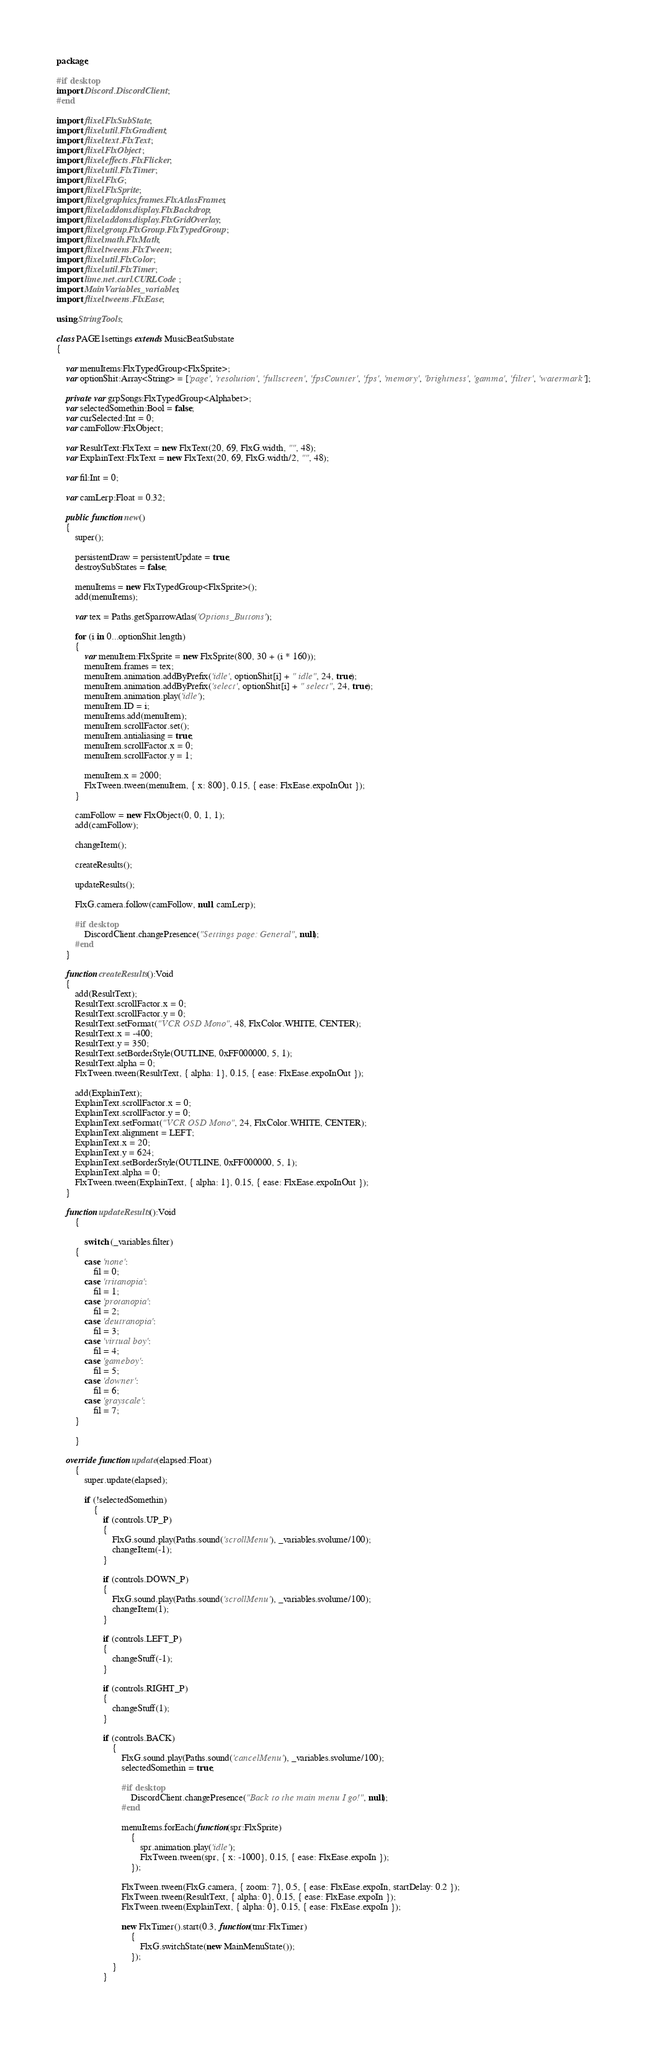Convert code to text. <code><loc_0><loc_0><loc_500><loc_500><_Haxe_>package;

#if desktop
import Discord.DiscordClient;
#end

import flixel.FlxSubState;
import flixel.util.FlxGradient;
import flixel.text.FlxText;
import flixel.FlxObject;
import flixel.effects.FlxFlicker;
import flixel.util.FlxTimer;
import flixel.FlxG;
import flixel.FlxSprite;
import flixel.graphics.frames.FlxAtlasFrames;
import flixel.addons.display.FlxBackdrop;
import flixel.addons.display.FlxGridOverlay;
import flixel.group.FlxGroup.FlxTypedGroup;
import flixel.math.FlxMath;
import flixel.tweens.FlxTween;
import flixel.util.FlxColor;
import flixel.util.FlxTimer;
import lime.net.curl.CURLCode;
import MainVariables._variables;
import flixel.tweens.FlxEase;

using StringTools;

class PAGE1settings extends MusicBeatSubstate
{

    var menuItems:FlxTypedGroup<FlxSprite>;
    var optionShit:Array<String> = ['page', 'resolution', 'fullscreen', 'fpsCounter', 'fps', 'memory', 'brightness', 'gamma', 'filter', 'watermark'];

    private var grpSongs:FlxTypedGroup<Alphabet>;
    var selectedSomethin:Bool = false;
    var curSelected:Int = 0;
    var camFollow:FlxObject;

    var ResultText:FlxText = new FlxText(20, 69, FlxG.width, "", 48);
    var ExplainText:FlxText = new FlxText(20, 69, FlxG.width/2, "", 48);

    var fil:Int = 0;

    var camLerp:Float = 0.32;

    public function new()
    {
        super();

        persistentDraw = persistentUpdate = true;
        destroySubStates = false;

        menuItems = new FlxTypedGroup<FlxSprite>();
        add(menuItems);
        
		var tex = Paths.getSparrowAtlas('Options_Buttons');

		for (i in 0...optionShit.length)
		{
			var menuItem:FlxSprite = new FlxSprite(800, 30 + (i * 160));
			menuItem.frames = tex;
            menuItem.animation.addByPrefix('idle', optionShit[i] + " idle", 24, true);
            menuItem.animation.addByPrefix('select', optionShit[i] + " select", 24, true);
			menuItem.animation.play('idle');
			menuItem.ID = i;
			menuItems.add(menuItem);
			menuItem.scrollFactor.set();
            menuItem.antialiasing = true;
            menuItem.scrollFactor.x = 0;
            menuItem.scrollFactor.y = 1;

            menuItem.x = 2000;
            FlxTween.tween(menuItem, { x: 800}, 0.15, { ease: FlxEase.expoInOut });
        }

        camFollow = new FlxObject(0, 0, 1, 1);
		add(camFollow);
        
        changeItem();

        createResults();

        updateResults();

        FlxG.camera.follow(camFollow, null, camLerp);

        #if desktop
			DiscordClient.changePresence("Settings page: General", null);
		#end
    }

    function createResults():Void
    {
        add(ResultText);
        ResultText.scrollFactor.x = 0;
        ResultText.scrollFactor.y = 0;
        ResultText.setFormat("VCR OSD Mono", 48, FlxColor.WHITE, CENTER);
        ResultText.x = -400;
        ResultText.y = 350;
        ResultText.setBorderStyle(OUTLINE, 0xFF000000, 5, 1);
        ResultText.alpha = 0;
        FlxTween.tween(ResultText, { alpha: 1}, 0.15, { ease: FlxEase.expoInOut });

        add(ExplainText);
        ExplainText.scrollFactor.x = 0;
        ExplainText.scrollFactor.y = 0;
        ExplainText.setFormat("VCR OSD Mono", 24, FlxColor.WHITE, CENTER);
        ExplainText.alignment = LEFT;
        ExplainText.x = 20;
        ExplainText.y = 624;
        ExplainText.setBorderStyle(OUTLINE, 0xFF000000, 5, 1);
        ExplainText.alpha = 0;
        FlxTween.tween(ExplainText, { alpha: 1}, 0.15, { ease: FlxEase.expoInOut });
    }

    function updateResults():Void
        {

            switch (_variables.filter)
        {
            case 'none':
                fil = 0;
            case 'tritanopia':
                fil = 1;
            case 'protanopia':
                fil = 2;
            case 'deutranopia':
                fil = 3;
            case 'virtual boy':
                fil = 4;
            case 'gameboy':
                fil = 5;
            case 'downer':
                fil = 6;
            case 'grayscale':
                fil = 7;
        }

        }

    override function update(elapsed:Float)
        {
            super.update(elapsed);

            if (!selectedSomethin)
                {
                    if (controls.UP_P)
                    {
                        FlxG.sound.play(Paths.sound('scrollMenu'), _variables.svolume/100);
                        changeItem(-1);
                    }
        
                    if (controls.DOWN_P)
                    {
                        FlxG.sound.play(Paths.sound('scrollMenu'), _variables.svolume/100);
                        changeItem(1);
                    }
			
				    if (controls.LEFT_P)
                    {
                        changeStuff(-1);
                    }
        
                    if (controls.RIGHT_P)
                    {
                        changeStuff(1);
                    }
                
                    if (controls.BACK)
                        {
                            FlxG.sound.play(Paths.sound('cancelMenu'), _variables.svolume/100);
                            selectedSomethin = true;

                            #if desktop
			                    DiscordClient.changePresence("Back to the main menu I go!", null);
		                    #end
    
                            menuItems.forEach(function(spr:FlxSprite)
                                {
                                    spr.animation.play('idle');
                                    FlxTween.tween(spr, { x: -1000}, 0.15, { ease: FlxEase.expoIn });
                                });
                            
                            FlxTween.tween(FlxG.camera, { zoom: 7}, 0.5, { ease: FlxEase.expoIn, startDelay: 0.2 });
                            FlxTween.tween(ResultText, { alpha: 0}, 0.15, { ease: FlxEase.expoIn });
                            FlxTween.tween(ExplainText, { alpha: 0}, 0.15, { ease: FlxEase.expoIn });
    
                            new FlxTimer().start(0.3, function(tmr:FlxTimer)
                                {
                                    FlxG.switchState(new MainMenuState());
                                });
                        }
                    }
            </code> 